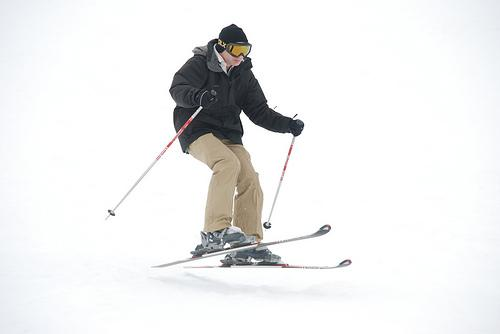What is the person's activity and what kind of terrain are they on? The person is skiing downhill on a snowy slope. What is the atmospheric condition depicted in the image? The image shows a bright day on a snowy slope. What color are the ski poles in the person's hand? The ski poles are red. What is the position of the person's right leg? The person's right leg is raised in the air. Briefly describe the overall scene in the image. A skier in a black jacket and tan pants is skiing downhill while holding red ski poles, wearing yellow goggles and a black hat, and has gray ski boots attached to his feet. Identify any possible safety equipment seen on the person. The person is wearing goggles for eye protection and a black hat for head warmth. Point out one unique feature on each of the skis. The right ski has a curve turned up at the end, and the left ski has a design on the front. List the colors of the various objects and clothing seen on the person. Red ski poles, black hat, black jacket, tan pants, gray ski boots, black gloves, yellow letters on goggles, white shirt collar. Count the number of objects related to the man's clothing in the image. There are 9 clothing-related objects: goggles, black hat, hood, black jacket, tan pants, gray ski boots, black gloves, white shirt collar, and yellow letters. Describe any visible interactions between the person and inanimate objects in the scene. The person is holding red ski poles in his gloved hands, and he has ski boots attached to gray skis, which are interacting with the snowy surface. There is also a shadow on the snow from the person and his gear. Describe the scene with the person and their attire. A person skiing down a slope wearing goggles, a black hat, a black jacket, tan pants, and gray ski shoes, holding red ski poles. What is the person doing in the snow? Skiing down a slope What type of facial accessory is the person wearing on their face? Goggles Identify the color of the ski shoes. Gray Describe the design on the front of the skis. There is a curve turned up at the tip of the skis. Create a short story about the person skiing in the scene. On a beautiful winter day, a skilled skier glided gracefully down the snowy slope, effortlessly navigating. The sun reflected off his yellow goggles, making the yellow letters on its side visible from a distance. The skier wore a fashionable black jacket and tan pants, perfectly blending style and function, while holding sturdy red ski poles aiding him in his descent. What type of pants is the skier wearing? Tan pants What is the color of the snow in the background? White Identify the position of the person's right leg in the air. Raised State the color of the person's goggles and mention if there are any letters on their side. The goggles are yellow and have yellow letters on the side. Is the person wearing a white shirt collar around their neck? Yes Which part of the person's outfit is red and silver? The ski poles Choose the correct statement: a) The person is wearing a knitted cap b) The person is wearing a blue cap c) The person has brown hair. a) The person is wearing a knitted cap What color are the ski poles in the person's hands? Red Is there a shadow on the surface of the snow? If yes, state the color of the shadow. Yes, there is a shadow on the snow, and it is black. Name an object in the person's hands. Red ski poles What type of jacket is the person wearing? Black snow jacket What is the color of the person's hat? Black 